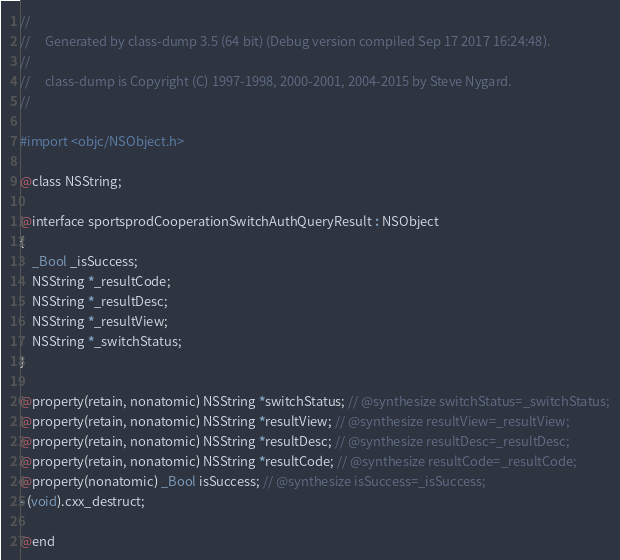<code> <loc_0><loc_0><loc_500><loc_500><_C_>//
//     Generated by class-dump 3.5 (64 bit) (Debug version compiled Sep 17 2017 16:24:48).
//
//     class-dump is Copyright (C) 1997-1998, 2000-2001, 2004-2015 by Steve Nygard.
//

#import <objc/NSObject.h>

@class NSString;

@interface sportsprodCooperationSwitchAuthQueryResult : NSObject
{
    _Bool _isSuccess;
    NSString *_resultCode;
    NSString *_resultDesc;
    NSString *_resultView;
    NSString *_switchStatus;
}

@property(retain, nonatomic) NSString *switchStatus; // @synthesize switchStatus=_switchStatus;
@property(retain, nonatomic) NSString *resultView; // @synthesize resultView=_resultView;
@property(retain, nonatomic) NSString *resultDesc; // @synthesize resultDesc=_resultDesc;
@property(retain, nonatomic) NSString *resultCode; // @synthesize resultCode=_resultCode;
@property(nonatomic) _Bool isSuccess; // @synthesize isSuccess=_isSuccess;
- (void).cxx_destruct;

@end

</code> 